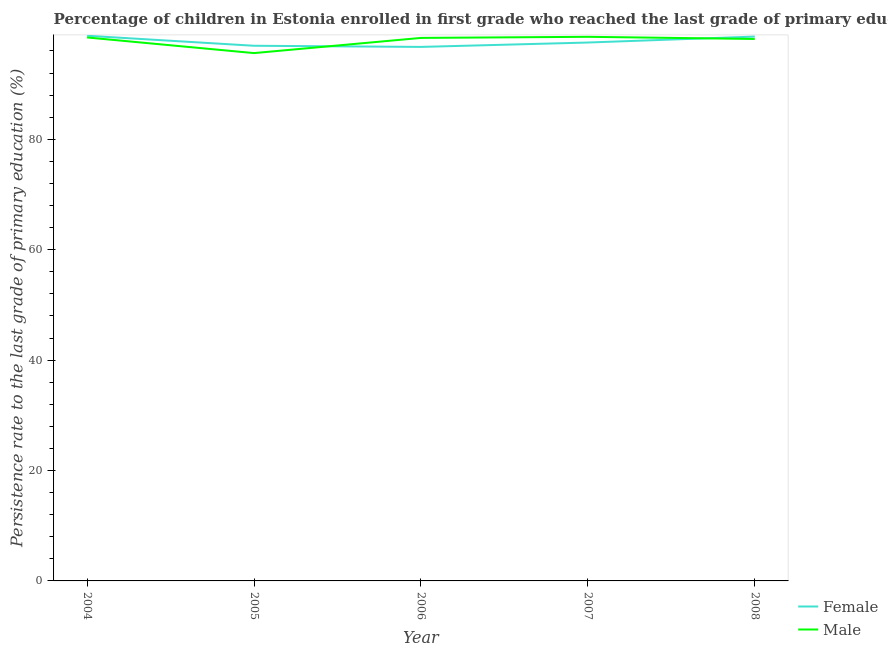How many different coloured lines are there?
Your answer should be compact. 2. Does the line corresponding to persistence rate of female students intersect with the line corresponding to persistence rate of male students?
Your answer should be very brief. Yes. Is the number of lines equal to the number of legend labels?
Provide a succinct answer. Yes. What is the persistence rate of male students in 2007?
Make the answer very short. 98.56. Across all years, what is the maximum persistence rate of female students?
Make the answer very short. 98.75. Across all years, what is the minimum persistence rate of male students?
Your response must be concise. 95.61. In which year was the persistence rate of female students minimum?
Offer a very short reply. 2006. What is the total persistence rate of male students in the graph?
Ensure brevity in your answer.  489.14. What is the difference between the persistence rate of female students in 2004 and that in 2005?
Offer a terse response. 1.81. What is the difference between the persistence rate of male students in 2005 and the persistence rate of female students in 2008?
Your answer should be compact. -2.99. What is the average persistence rate of female students per year?
Ensure brevity in your answer.  97.71. In the year 2006, what is the difference between the persistence rate of male students and persistence rate of female students?
Give a very brief answer. 1.63. In how many years, is the persistence rate of female students greater than 72 %?
Your answer should be very brief. 5. What is the ratio of the persistence rate of female students in 2005 to that in 2007?
Make the answer very short. 0.99. What is the difference between the highest and the second highest persistence rate of male students?
Ensure brevity in your answer.  0.12. What is the difference between the highest and the lowest persistence rate of male students?
Offer a very short reply. 2.95. Does the persistence rate of female students monotonically increase over the years?
Give a very brief answer. No. Is the persistence rate of male students strictly greater than the persistence rate of female students over the years?
Your response must be concise. No. Is the persistence rate of female students strictly less than the persistence rate of male students over the years?
Offer a terse response. No. How many years are there in the graph?
Give a very brief answer. 5. Where does the legend appear in the graph?
Your answer should be compact. Bottom right. How are the legend labels stacked?
Offer a terse response. Vertical. What is the title of the graph?
Your answer should be very brief. Percentage of children in Estonia enrolled in first grade who reached the last grade of primary education. Does "Automatic Teller Machines" appear as one of the legend labels in the graph?
Offer a very short reply. No. What is the label or title of the X-axis?
Give a very brief answer. Year. What is the label or title of the Y-axis?
Your answer should be compact. Persistence rate to the last grade of primary education (%). What is the Persistence rate to the last grade of primary education (%) of Female in 2004?
Keep it short and to the point. 98.75. What is the Persistence rate to the last grade of primary education (%) in Male in 2004?
Offer a terse response. 98.44. What is the Persistence rate to the last grade of primary education (%) of Female in 2005?
Ensure brevity in your answer.  96.94. What is the Persistence rate to the last grade of primary education (%) in Male in 2005?
Keep it short and to the point. 95.61. What is the Persistence rate to the last grade of primary education (%) of Female in 2006?
Your response must be concise. 96.73. What is the Persistence rate to the last grade of primary education (%) in Male in 2006?
Give a very brief answer. 98.36. What is the Persistence rate to the last grade of primary education (%) of Female in 2007?
Your answer should be compact. 97.52. What is the Persistence rate to the last grade of primary education (%) in Male in 2007?
Your answer should be compact. 98.56. What is the Persistence rate to the last grade of primary education (%) in Female in 2008?
Keep it short and to the point. 98.6. What is the Persistence rate to the last grade of primary education (%) in Male in 2008?
Provide a short and direct response. 98.17. Across all years, what is the maximum Persistence rate to the last grade of primary education (%) in Female?
Give a very brief answer. 98.75. Across all years, what is the maximum Persistence rate to the last grade of primary education (%) of Male?
Your answer should be compact. 98.56. Across all years, what is the minimum Persistence rate to the last grade of primary education (%) in Female?
Make the answer very short. 96.73. Across all years, what is the minimum Persistence rate to the last grade of primary education (%) of Male?
Offer a very short reply. 95.61. What is the total Persistence rate to the last grade of primary education (%) in Female in the graph?
Provide a short and direct response. 488.55. What is the total Persistence rate to the last grade of primary education (%) of Male in the graph?
Your response must be concise. 489.14. What is the difference between the Persistence rate to the last grade of primary education (%) of Female in 2004 and that in 2005?
Ensure brevity in your answer.  1.81. What is the difference between the Persistence rate to the last grade of primary education (%) in Male in 2004 and that in 2005?
Provide a short and direct response. 2.83. What is the difference between the Persistence rate to the last grade of primary education (%) in Female in 2004 and that in 2006?
Offer a terse response. 2.02. What is the difference between the Persistence rate to the last grade of primary education (%) in Male in 2004 and that in 2006?
Provide a short and direct response. 0.08. What is the difference between the Persistence rate to the last grade of primary education (%) in Female in 2004 and that in 2007?
Ensure brevity in your answer.  1.23. What is the difference between the Persistence rate to the last grade of primary education (%) in Male in 2004 and that in 2007?
Offer a terse response. -0.12. What is the difference between the Persistence rate to the last grade of primary education (%) in Female in 2004 and that in 2008?
Keep it short and to the point. 0.15. What is the difference between the Persistence rate to the last grade of primary education (%) of Male in 2004 and that in 2008?
Ensure brevity in your answer.  0.28. What is the difference between the Persistence rate to the last grade of primary education (%) in Female in 2005 and that in 2006?
Keep it short and to the point. 0.21. What is the difference between the Persistence rate to the last grade of primary education (%) of Male in 2005 and that in 2006?
Offer a very short reply. -2.75. What is the difference between the Persistence rate to the last grade of primary education (%) in Female in 2005 and that in 2007?
Provide a short and direct response. -0.59. What is the difference between the Persistence rate to the last grade of primary education (%) in Male in 2005 and that in 2007?
Offer a terse response. -2.95. What is the difference between the Persistence rate to the last grade of primary education (%) of Female in 2005 and that in 2008?
Make the answer very short. -1.66. What is the difference between the Persistence rate to the last grade of primary education (%) of Male in 2005 and that in 2008?
Provide a short and direct response. -2.56. What is the difference between the Persistence rate to the last grade of primary education (%) in Female in 2006 and that in 2007?
Your answer should be very brief. -0.79. What is the difference between the Persistence rate to the last grade of primary education (%) in Male in 2006 and that in 2007?
Make the answer very short. -0.2. What is the difference between the Persistence rate to the last grade of primary education (%) of Female in 2006 and that in 2008?
Offer a terse response. -1.87. What is the difference between the Persistence rate to the last grade of primary education (%) in Male in 2006 and that in 2008?
Give a very brief answer. 0.19. What is the difference between the Persistence rate to the last grade of primary education (%) in Female in 2007 and that in 2008?
Your response must be concise. -1.08. What is the difference between the Persistence rate to the last grade of primary education (%) in Male in 2007 and that in 2008?
Your response must be concise. 0.39. What is the difference between the Persistence rate to the last grade of primary education (%) of Female in 2004 and the Persistence rate to the last grade of primary education (%) of Male in 2005?
Your response must be concise. 3.14. What is the difference between the Persistence rate to the last grade of primary education (%) in Female in 2004 and the Persistence rate to the last grade of primary education (%) in Male in 2006?
Make the answer very short. 0.39. What is the difference between the Persistence rate to the last grade of primary education (%) in Female in 2004 and the Persistence rate to the last grade of primary education (%) in Male in 2007?
Your answer should be very brief. 0.19. What is the difference between the Persistence rate to the last grade of primary education (%) in Female in 2004 and the Persistence rate to the last grade of primary education (%) in Male in 2008?
Ensure brevity in your answer.  0.58. What is the difference between the Persistence rate to the last grade of primary education (%) in Female in 2005 and the Persistence rate to the last grade of primary education (%) in Male in 2006?
Ensure brevity in your answer.  -1.42. What is the difference between the Persistence rate to the last grade of primary education (%) in Female in 2005 and the Persistence rate to the last grade of primary education (%) in Male in 2007?
Offer a very short reply. -1.62. What is the difference between the Persistence rate to the last grade of primary education (%) in Female in 2005 and the Persistence rate to the last grade of primary education (%) in Male in 2008?
Offer a very short reply. -1.23. What is the difference between the Persistence rate to the last grade of primary education (%) of Female in 2006 and the Persistence rate to the last grade of primary education (%) of Male in 2007?
Offer a terse response. -1.83. What is the difference between the Persistence rate to the last grade of primary education (%) in Female in 2006 and the Persistence rate to the last grade of primary education (%) in Male in 2008?
Offer a very short reply. -1.44. What is the difference between the Persistence rate to the last grade of primary education (%) in Female in 2007 and the Persistence rate to the last grade of primary education (%) in Male in 2008?
Provide a short and direct response. -0.64. What is the average Persistence rate to the last grade of primary education (%) in Female per year?
Provide a succinct answer. 97.71. What is the average Persistence rate to the last grade of primary education (%) in Male per year?
Give a very brief answer. 97.83. In the year 2004, what is the difference between the Persistence rate to the last grade of primary education (%) in Female and Persistence rate to the last grade of primary education (%) in Male?
Your response must be concise. 0.31. In the year 2005, what is the difference between the Persistence rate to the last grade of primary education (%) in Female and Persistence rate to the last grade of primary education (%) in Male?
Provide a short and direct response. 1.33. In the year 2006, what is the difference between the Persistence rate to the last grade of primary education (%) in Female and Persistence rate to the last grade of primary education (%) in Male?
Provide a short and direct response. -1.63. In the year 2007, what is the difference between the Persistence rate to the last grade of primary education (%) in Female and Persistence rate to the last grade of primary education (%) in Male?
Keep it short and to the point. -1.03. In the year 2008, what is the difference between the Persistence rate to the last grade of primary education (%) of Female and Persistence rate to the last grade of primary education (%) of Male?
Give a very brief answer. 0.43. What is the ratio of the Persistence rate to the last grade of primary education (%) of Female in 2004 to that in 2005?
Make the answer very short. 1.02. What is the ratio of the Persistence rate to the last grade of primary education (%) of Male in 2004 to that in 2005?
Offer a very short reply. 1.03. What is the ratio of the Persistence rate to the last grade of primary education (%) of Female in 2004 to that in 2006?
Provide a short and direct response. 1.02. What is the ratio of the Persistence rate to the last grade of primary education (%) in Male in 2004 to that in 2006?
Provide a succinct answer. 1. What is the ratio of the Persistence rate to the last grade of primary education (%) in Female in 2004 to that in 2007?
Your answer should be compact. 1.01. What is the ratio of the Persistence rate to the last grade of primary education (%) in Male in 2004 to that in 2007?
Make the answer very short. 1. What is the ratio of the Persistence rate to the last grade of primary education (%) in Female in 2004 to that in 2008?
Keep it short and to the point. 1. What is the ratio of the Persistence rate to the last grade of primary education (%) of Male in 2005 to that in 2007?
Make the answer very short. 0.97. What is the ratio of the Persistence rate to the last grade of primary education (%) of Female in 2005 to that in 2008?
Ensure brevity in your answer.  0.98. What is the ratio of the Persistence rate to the last grade of primary education (%) of Male in 2005 to that in 2008?
Make the answer very short. 0.97. What is the ratio of the Persistence rate to the last grade of primary education (%) of Male in 2006 to that in 2007?
Your response must be concise. 1. What is the ratio of the Persistence rate to the last grade of primary education (%) of Male in 2007 to that in 2008?
Your answer should be very brief. 1. What is the difference between the highest and the second highest Persistence rate to the last grade of primary education (%) of Female?
Ensure brevity in your answer.  0.15. What is the difference between the highest and the second highest Persistence rate to the last grade of primary education (%) in Male?
Offer a very short reply. 0.12. What is the difference between the highest and the lowest Persistence rate to the last grade of primary education (%) of Female?
Offer a terse response. 2.02. What is the difference between the highest and the lowest Persistence rate to the last grade of primary education (%) of Male?
Keep it short and to the point. 2.95. 